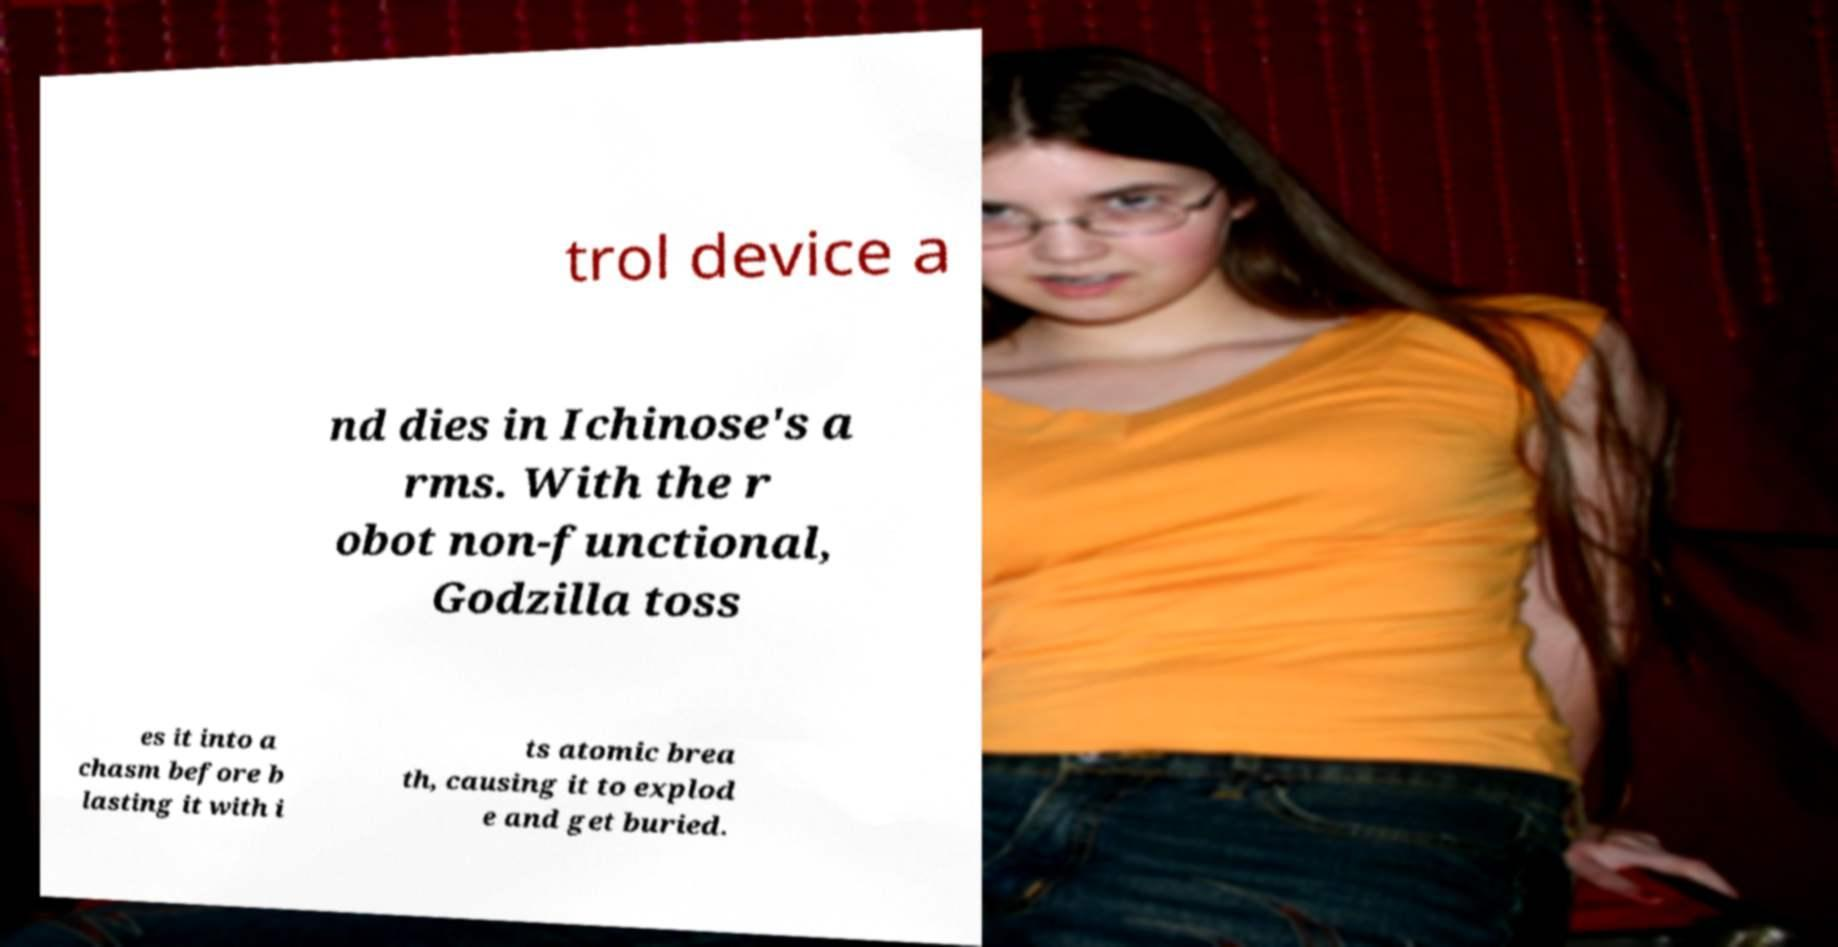There's text embedded in this image that I need extracted. Can you transcribe it verbatim? trol device a nd dies in Ichinose's a rms. With the r obot non-functional, Godzilla toss es it into a chasm before b lasting it with i ts atomic brea th, causing it to explod e and get buried. 